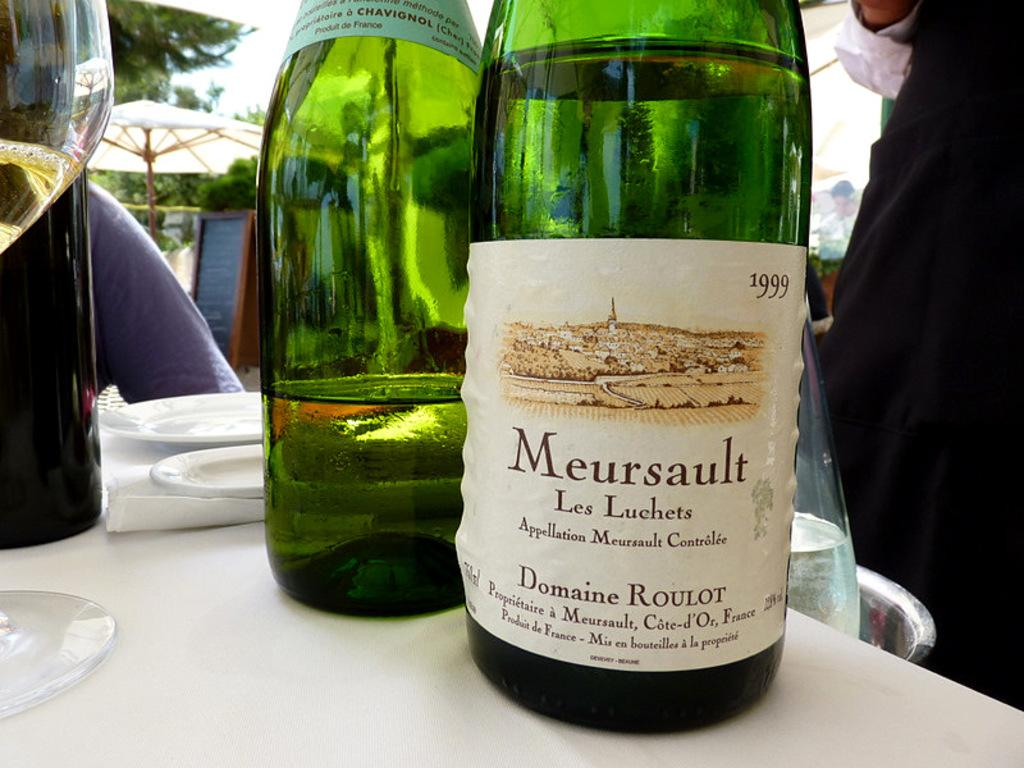<image>
Create a compact narrative representing the image presented. A bottle of alcohol is labeled with the Meursault name. 